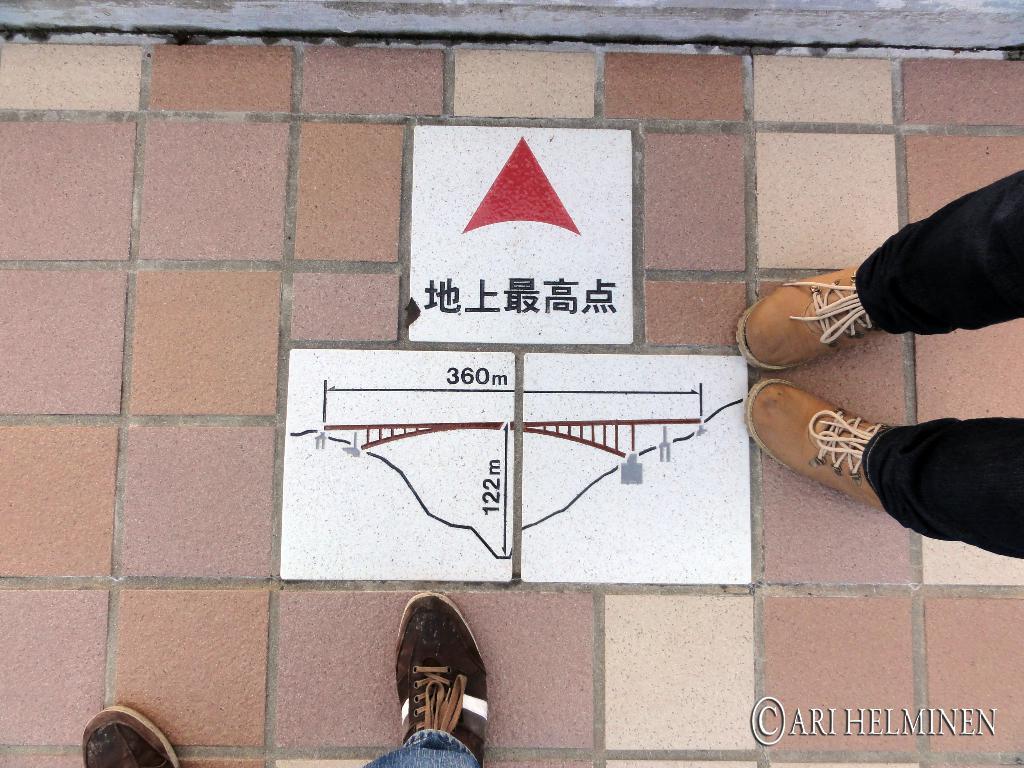How would you summarize this image in a sentence or two? We can see persons legs on the surface and worn footwear and we can see some measurements on white surface. 